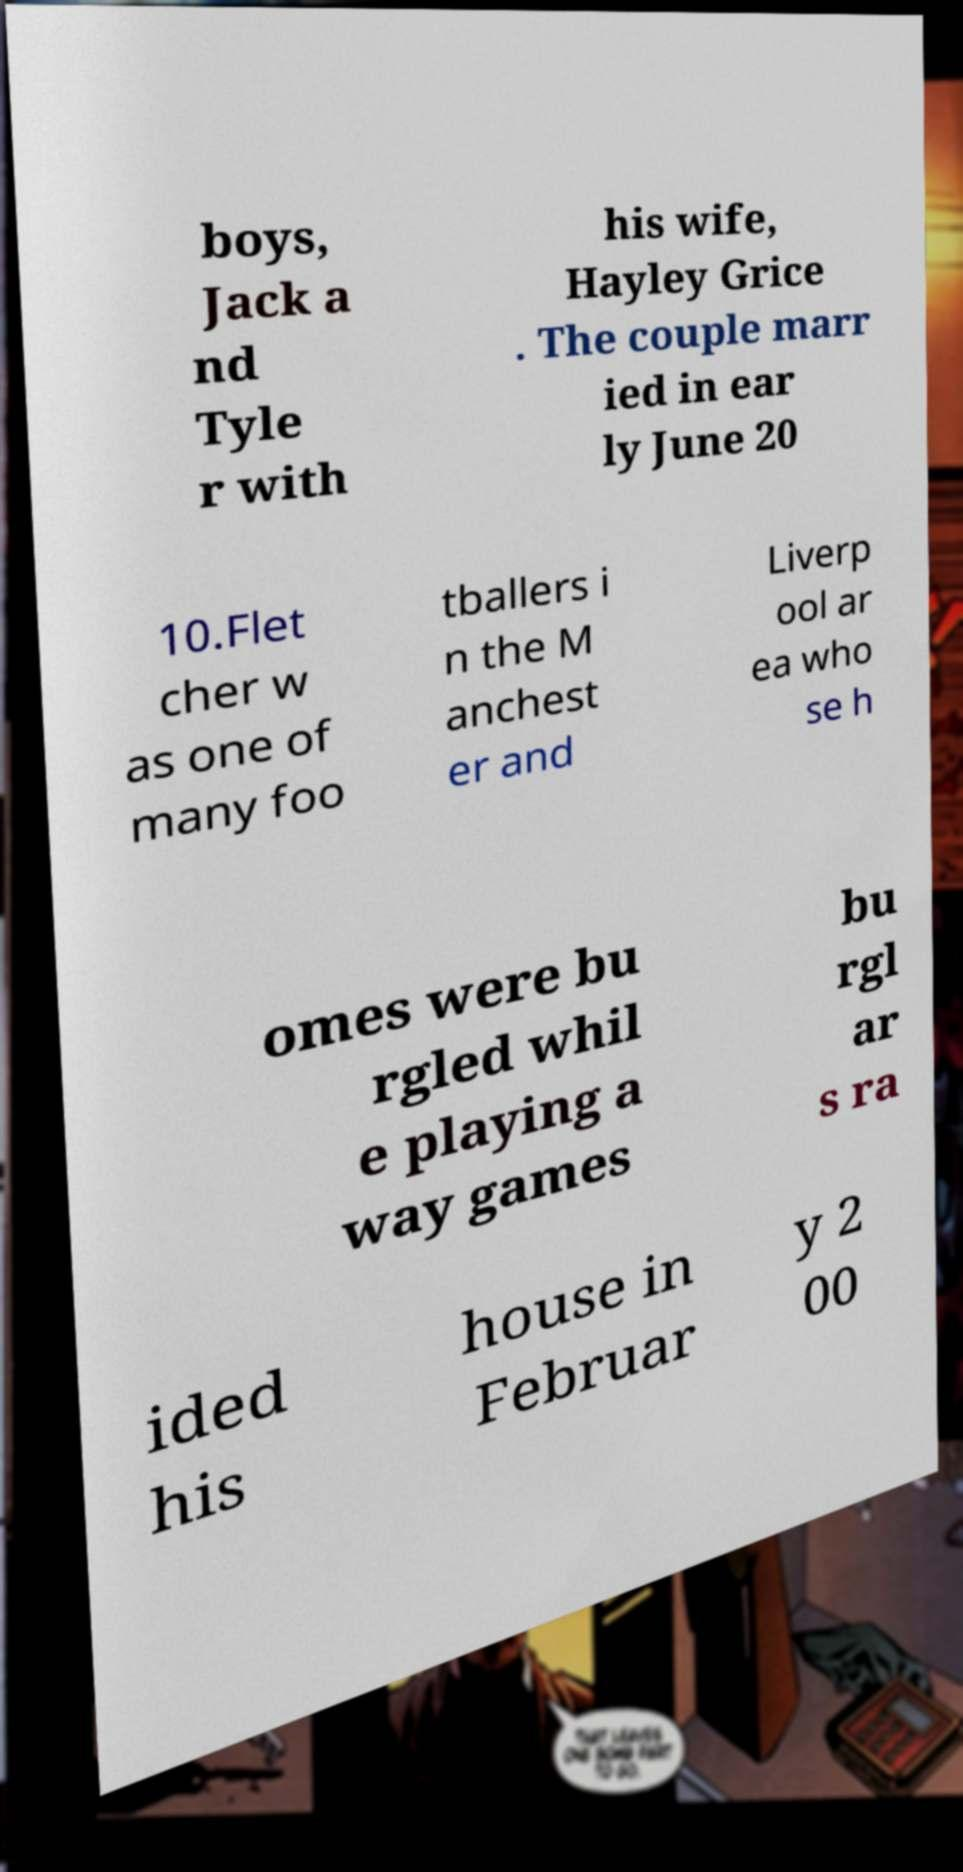Could you assist in decoding the text presented in this image and type it out clearly? boys, Jack a nd Tyle r with his wife, Hayley Grice . The couple marr ied in ear ly June 20 10.Flet cher w as one of many foo tballers i n the M anchest er and Liverp ool ar ea who se h omes were bu rgled whil e playing a way games bu rgl ar s ra ided his house in Februar y 2 00 